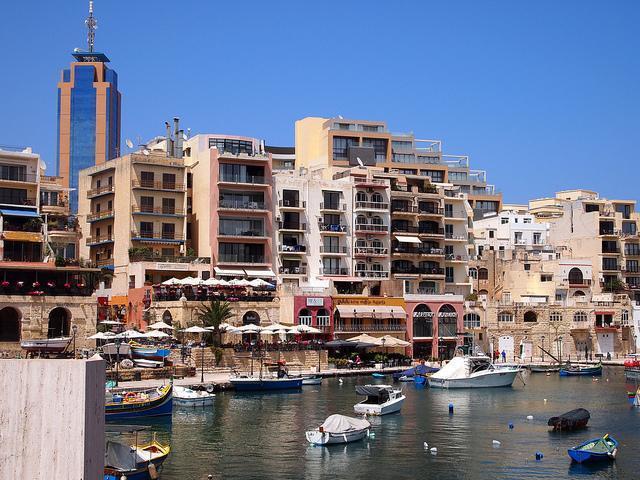How many boats are in the picture?
Give a very brief answer. 3. How many trains are visible?
Give a very brief answer. 0. 